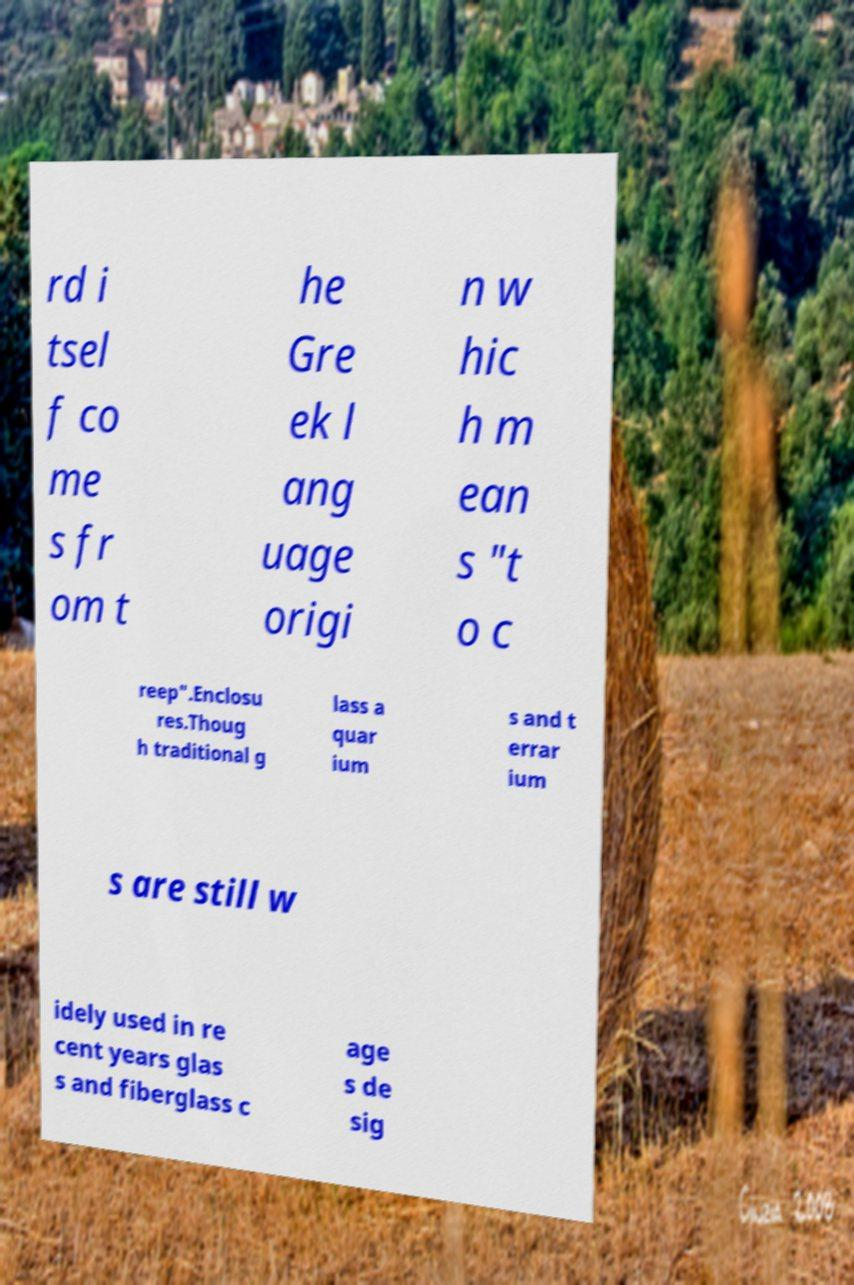Please read and relay the text visible in this image. What does it say? rd i tsel f co me s fr om t he Gre ek l ang uage origi n w hic h m ean s "t o c reep".Enclosu res.Thoug h traditional g lass a quar ium s and t errar ium s are still w idely used in re cent years glas s and fiberglass c age s de sig 